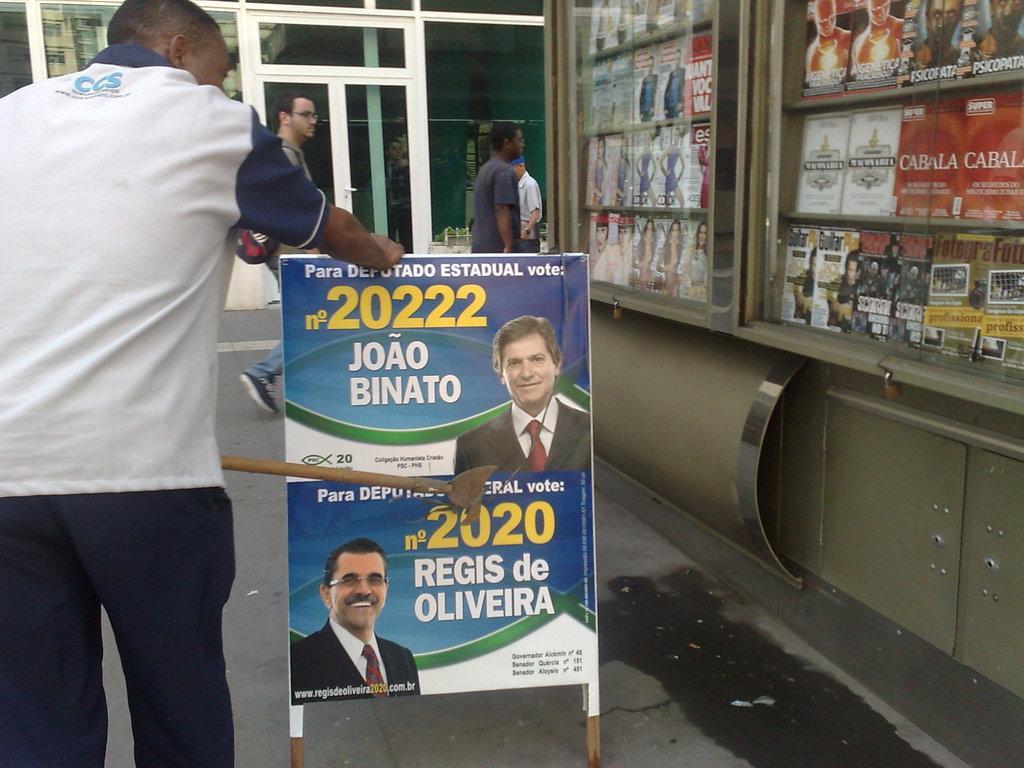How would you summarize this image in a sentence or two? The person standing in the left corner placed his hands on a banner in front of him, Which has something written on it and there are some other objects beside it. 